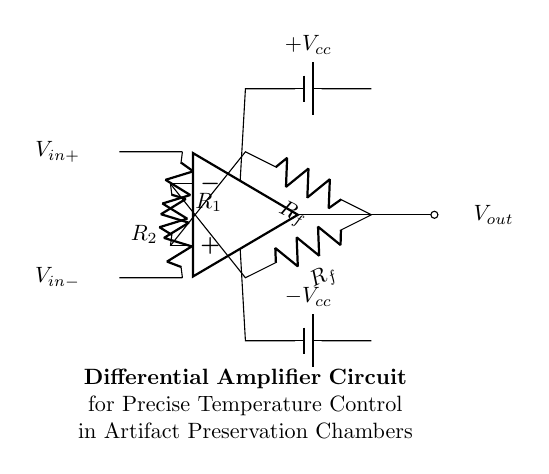What type of amplifier is shown in the circuit? The circuit is a differential amplifier, which specifically amplifies the difference between two input voltages. This can be deduced by the presence of two input terminals and the use of an operational amplifier as the main component.
Answer: Differential amplifier What are the names of the input voltages? The input voltages are labeled as V-in-plus and V-in-minus. V-in-plus is connected to the non-inverting terminal of the op-amp, while V-in-minus is connected to the inverting terminal.
Answer: V-in-plus and V-in-minus How many feedback resistors are present in the circuit? There are two feedback resistors. Each resistor is connected to the output of the op-amp and forms feedback for the circuit, influencing the gain of the amplifier.
Answer: Two What is the significance of the feedback resistors in this circuit? The feedback resistors help control the gain of the differential amplifier. They set the proportion of output voltage that is fed back into the input, thereby stabilizing and determining the amplification factor based on the resistor values.
Answer: Control gain What are the power supply voltages used in this circuit? The power supply voltages are labeled as plus V-cc and minus V-cc. These voltages are essential for the operation of the op-amp, allowing it to amplify the input signals effectively.
Answer: Plus V-cc and minus V-cc What would happen if one of the input voltages is significantly higher than the other? If one input voltage is significantly higher than the other, the output will be driven towards the maximum positive voltage or the maximum negative voltage, depending on which input is higher, potentially leading to saturation of the amplifier if not designed to handle such conditions.
Answer: Output saturation 